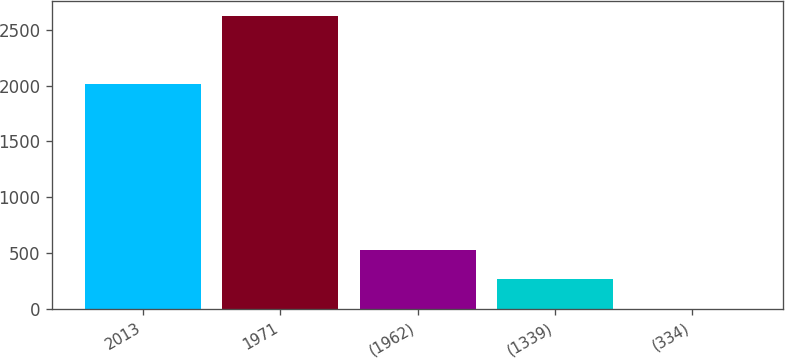<chart> <loc_0><loc_0><loc_500><loc_500><bar_chart><fcel>2013<fcel>1971<fcel>(1962)<fcel>(1339)<fcel>(334)<nl><fcel>2013<fcel>2624<fcel>525.21<fcel>262.86<fcel>0.51<nl></chart> 